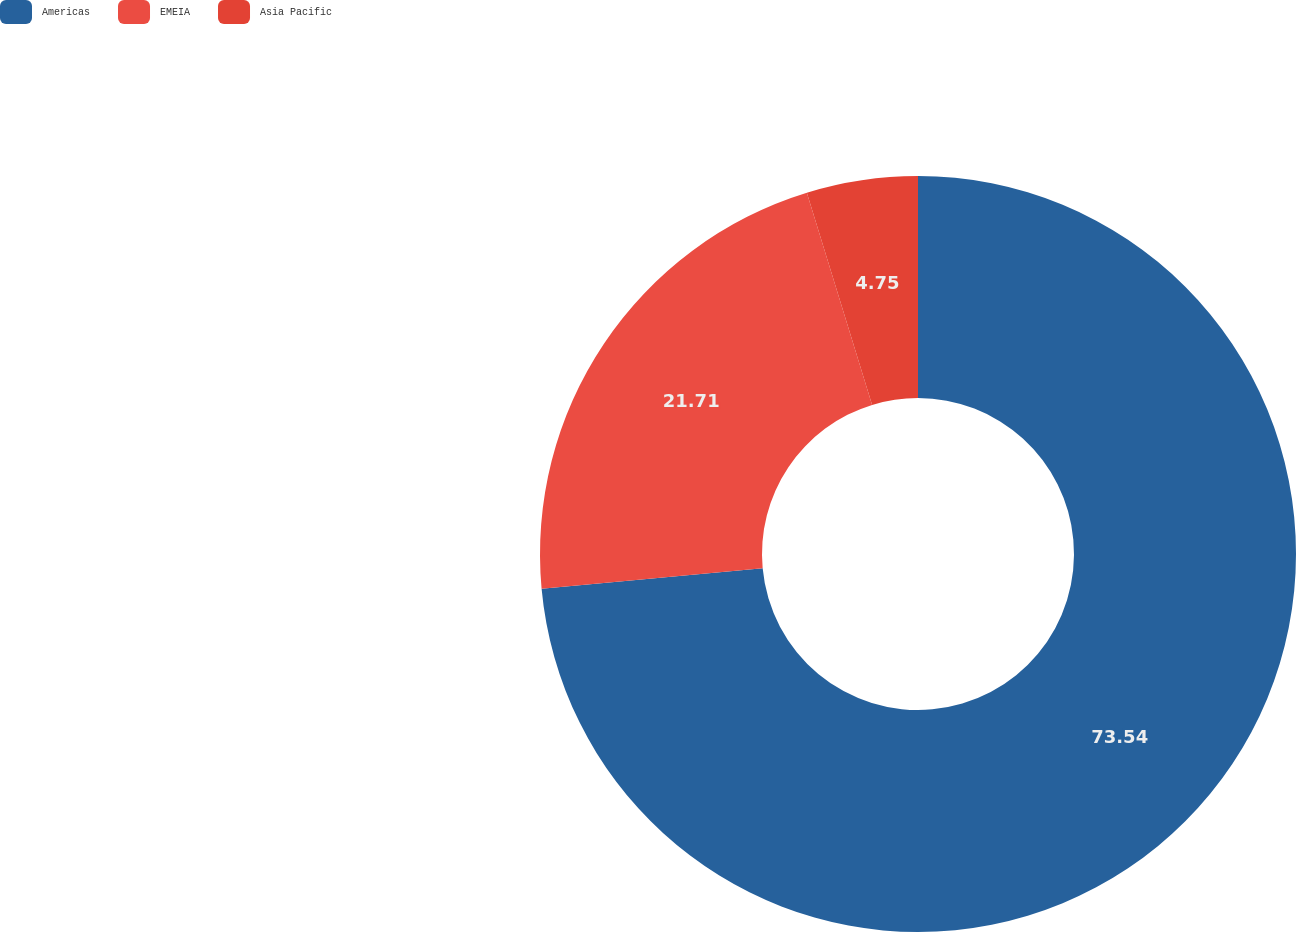<chart> <loc_0><loc_0><loc_500><loc_500><pie_chart><fcel>Americas<fcel>EMEIA<fcel>Asia Pacific<nl><fcel>73.53%<fcel>21.71%<fcel>4.75%<nl></chart> 